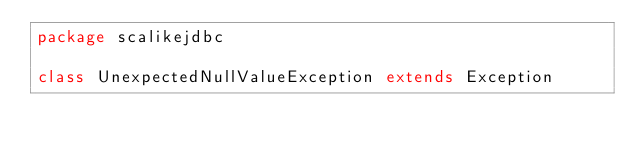<code> <loc_0><loc_0><loc_500><loc_500><_Scala_>package scalikejdbc

class UnexpectedNullValueException extends Exception
</code> 